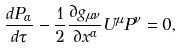Convert formula to latex. <formula><loc_0><loc_0><loc_500><loc_500>\frac { d P _ { \alpha } } { d \tau } - \frac { 1 } { 2 } \frac { \partial g _ { \mu \nu } } { \partial x ^ { \alpha } } U ^ { \mu } P ^ { \nu } = 0 ,</formula> 